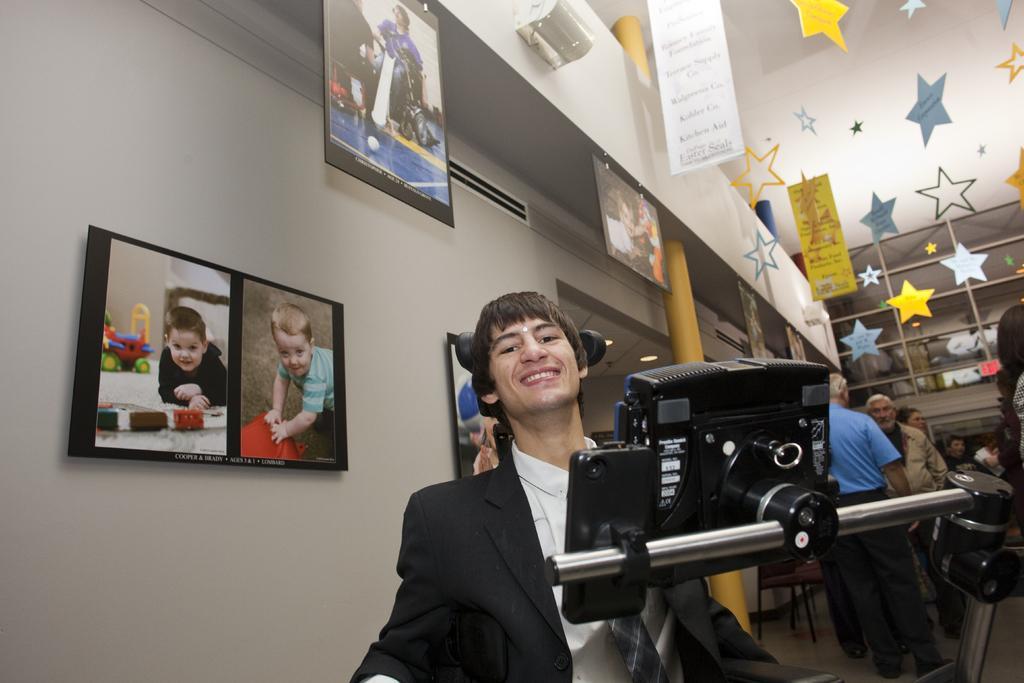Describe this image in one or two sentences. Pictures are on wall. Here we can see a mobile and camera are on stand. This man wore suit. Background there are people, stars and banners. 